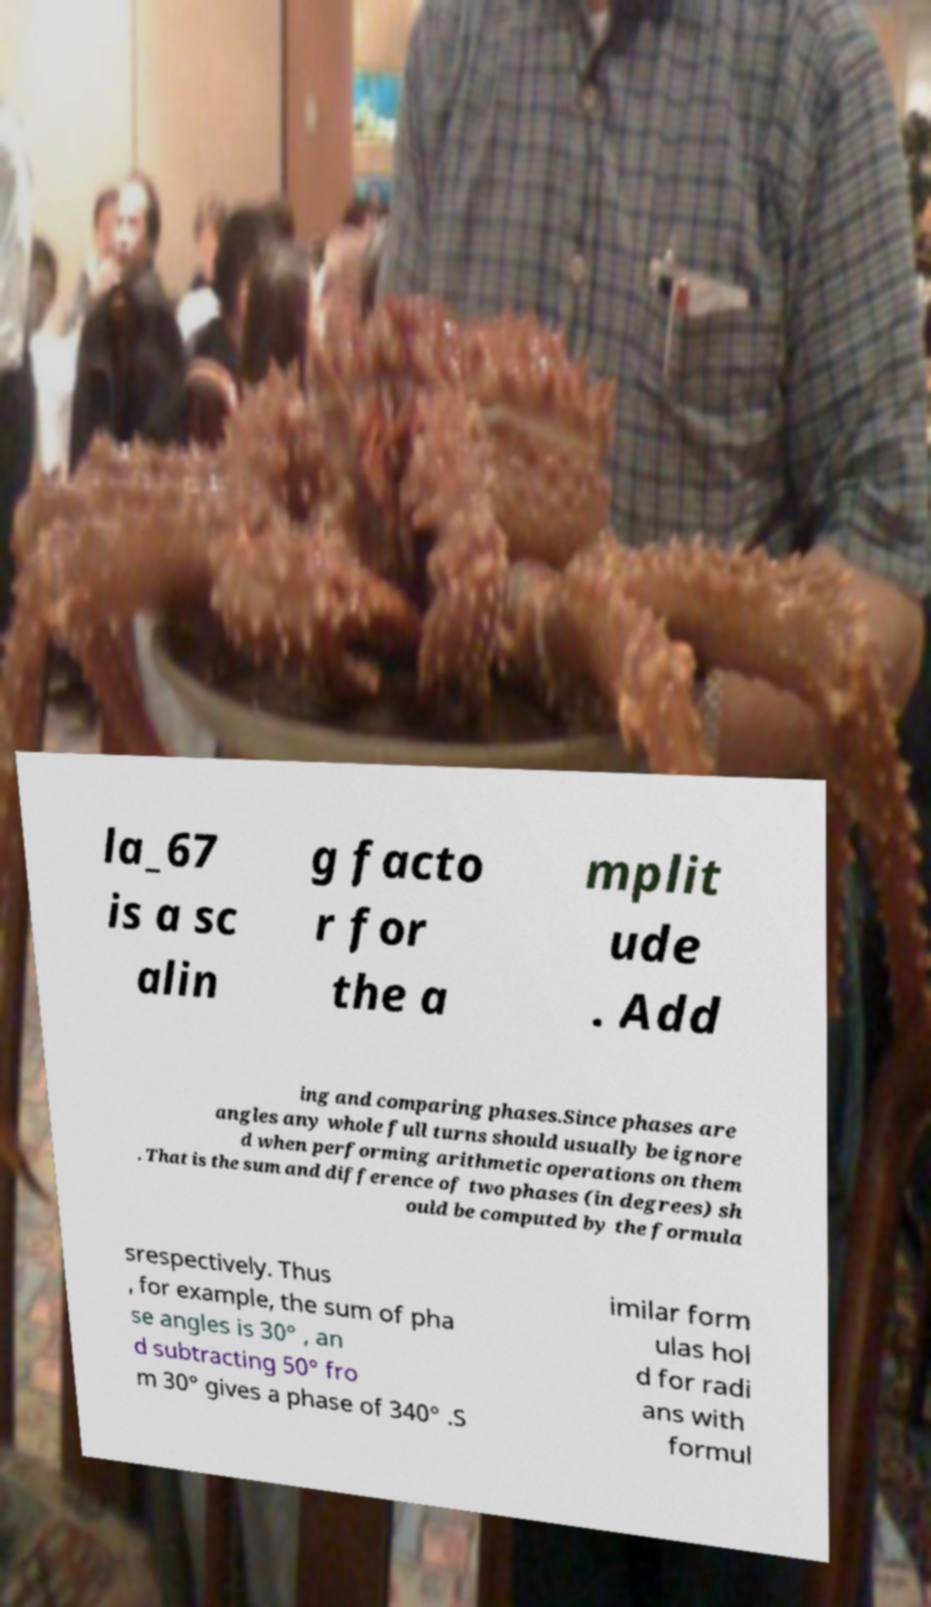Can you accurately transcribe the text from the provided image for me? la_67 is a sc alin g facto r for the a mplit ude . Add ing and comparing phases.Since phases are angles any whole full turns should usually be ignore d when performing arithmetic operations on them . That is the sum and difference of two phases (in degrees) sh ould be computed by the formula srespectively. Thus , for example, the sum of pha se angles is 30° , an d subtracting 50° fro m 30° gives a phase of 340° .S imilar form ulas hol d for radi ans with formul 